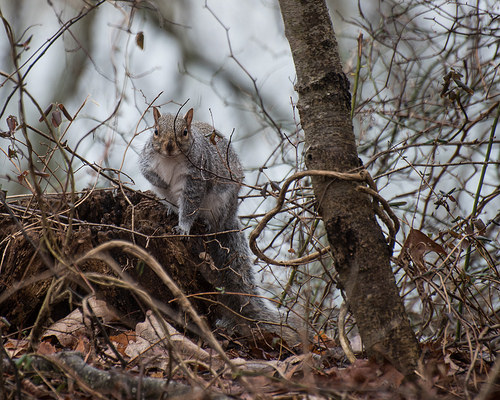<image>
Is there a squirrel behind the branches? Yes. From this viewpoint, the squirrel is positioned behind the branches, with the branches partially or fully occluding the squirrel. Where is the rabbit in relation to the tree? Is it under the tree? Yes. The rabbit is positioned underneath the tree, with the tree above it in the vertical space. 